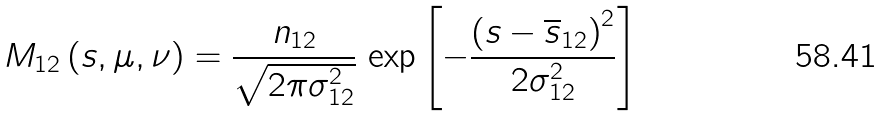<formula> <loc_0><loc_0><loc_500><loc_500>M _ { 1 2 } \left ( s , \mu , \nu \right ) = \frac { n _ { 1 2 } } { \sqrt { 2 \pi \sigma _ { 1 2 } ^ { 2 } } } \, \exp \left [ - \frac { \left ( s - \overline { s } _ { 1 2 } \right ) ^ { 2 } } { 2 \sigma _ { 1 2 } ^ { 2 } } \right ]</formula> 